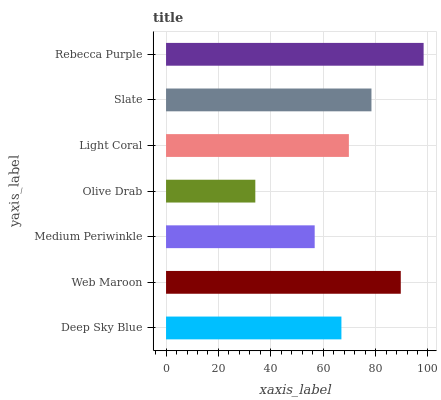Is Olive Drab the minimum?
Answer yes or no. Yes. Is Rebecca Purple the maximum?
Answer yes or no. Yes. Is Web Maroon the minimum?
Answer yes or no. No. Is Web Maroon the maximum?
Answer yes or no. No. Is Web Maroon greater than Deep Sky Blue?
Answer yes or no. Yes. Is Deep Sky Blue less than Web Maroon?
Answer yes or no. Yes. Is Deep Sky Blue greater than Web Maroon?
Answer yes or no. No. Is Web Maroon less than Deep Sky Blue?
Answer yes or no. No. Is Light Coral the high median?
Answer yes or no. Yes. Is Light Coral the low median?
Answer yes or no. Yes. Is Deep Sky Blue the high median?
Answer yes or no. No. Is Web Maroon the low median?
Answer yes or no. No. 